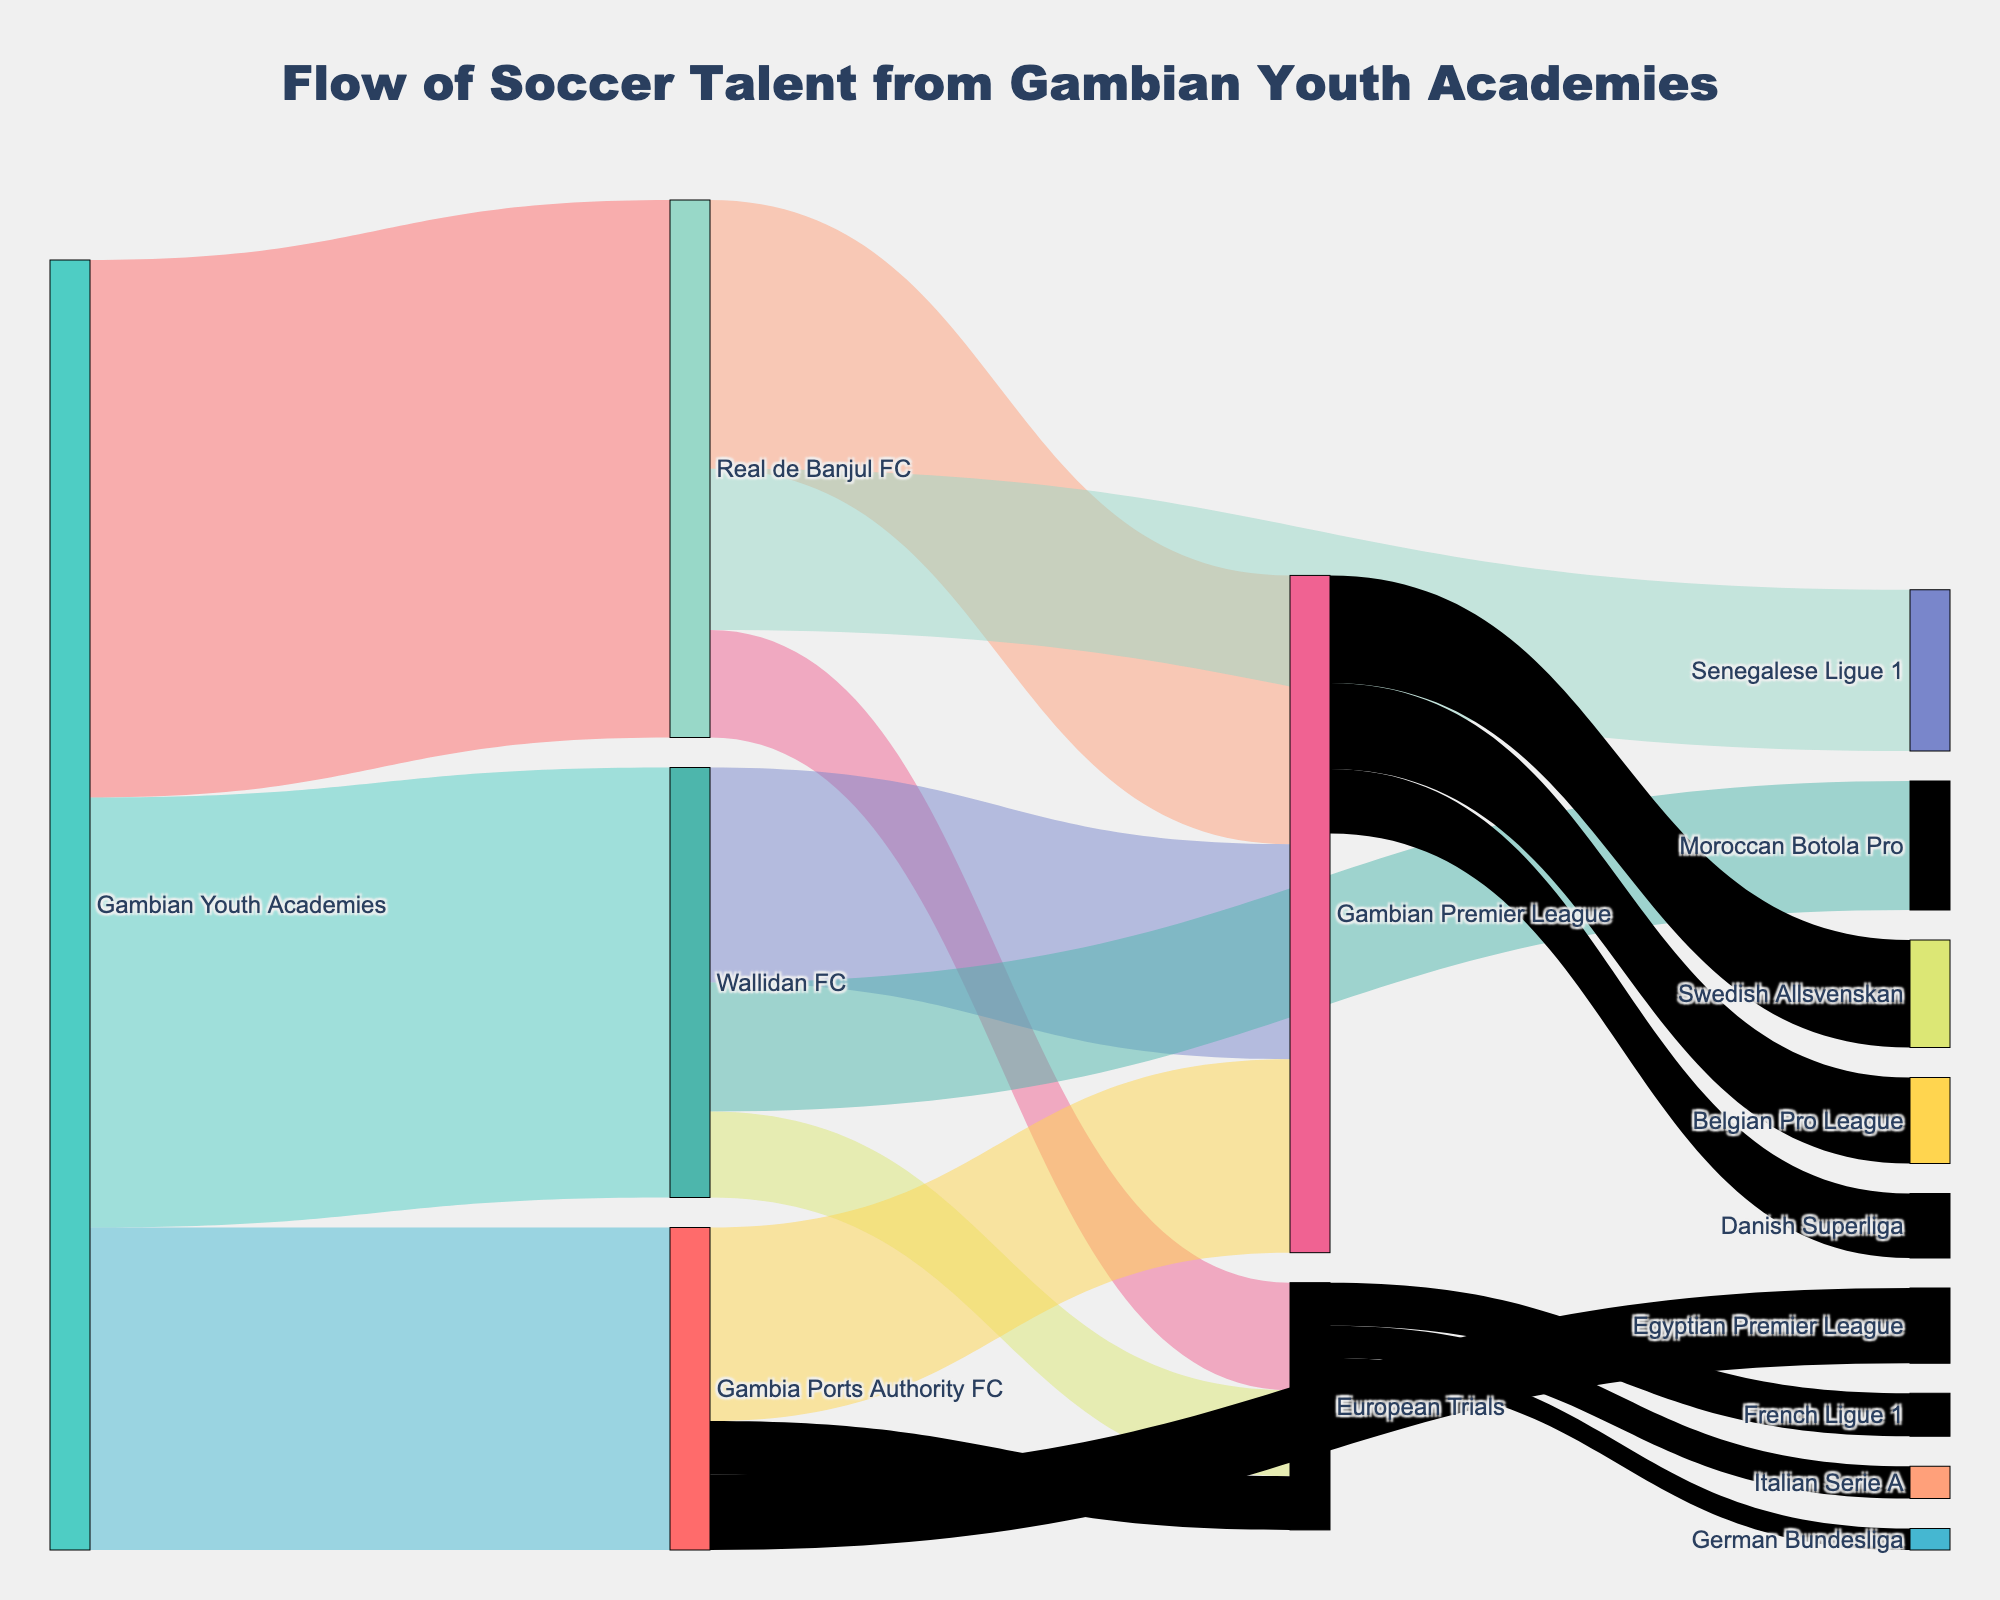Which Gambian youth academy has the most players moving to Real de Banjul FC? According to the diagram, the flow from Gambian Youth Academies to Real de Banjul FC is represented by the thickest line, indicating it has the largest number of players at 50.
Answer: Real de Banjul FC Which destination out of the Gambian Premier League, Senegalese Ligue 1, or European Trials receives the fewest players from Real de Banjul FC? By observing the lines emerging from Real de Banjul FC, European Trials have the thinnest line with 10 players, fewer than the Senegalese Ligue 1 with 15 and the Gambian Premier League with 25.
Answer: European Trials How many total players move from Gambian Youth Academies to professional leagues outside of Gambia? Sum up the values for Gambian Youth Academies to Senegalese Ligue 1 (15), Moroccan Botola Pro (12), and Egyptian Premier League (7).
Answer: 34 Which professional league receives the most players from the Gambian Premier League? By comparing the lines from Gambian Premier League, the Swedish Allsvenskan receives 10, the highest compared to the Belgian Pro League (8) and Danish Superliga (6).
Answer: Swedish Allsvenskan What is the total number of players going through European Trials before moving to other professional leagues? Sum the values of players moving from European Trials to Italian Serie A (3), French Ligue 1 (4), and German Bundesliga (2) from the diagram.
Answer: 9 Which Gambian club exports the fewest players to international trials? By comparing lines to European Trials, Gambia Ports Authority FC exports the fewest with 5, compared to Wallidan FC with 8, and Real de Banjul FC with 10.
Answer: Gambia Ports Authority FC How many players move from Gambian Youth Academies to Gambian Premier League, directly and indirectly through other clubs? Sum up all the values of lines ending in Gambian Premier League (25 from Real de Banjul FC, 20 from Wallidan FC, and 18 from Gambia Ports Authority FC) and directly from gambian youth academies
Answer: 63 What percentage of players from Gambian Youth Academies advance to Real de Banjul FC? Divide the number of players going to Real de Banjul FC (50) by the total number of players in the figure (sum of all flows = 109) and convert to a percentage. 50/120 * 100 = 41.67%.
Answer: 41.67% Which African league apart from Gambia receives the most players from Gambian youth academies? By inspecting the diagram for destinations outside Gambia, the Moroccan Botola Pro receives 12 players, more than the Senegalese Ligue 1 and Egyptian Premier League.
Answer: Moroccan Botola Pro Which transition sees the largest movement of players, and how many players are involved? The thickest line in the diagram indicates the largest transition. From Gambian Youth Academies to Real de Banjul FC sees 50 players.
Answer: 50 